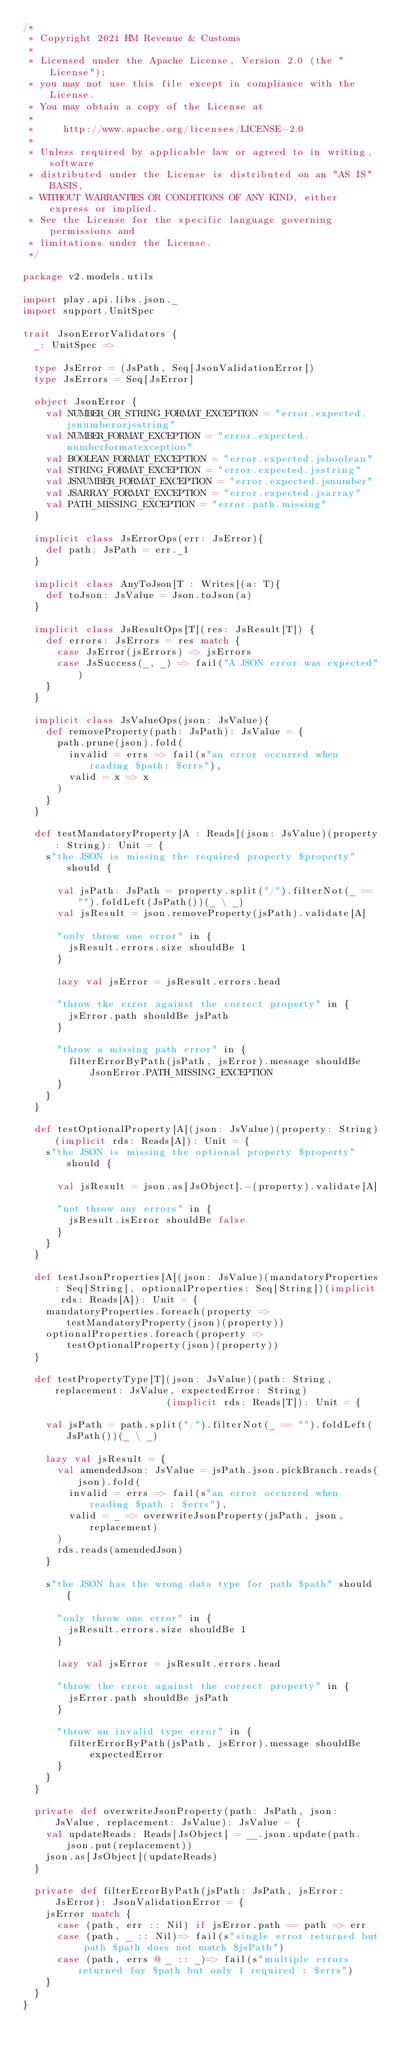Convert code to text. <code><loc_0><loc_0><loc_500><loc_500><_Scala_>/*
 * Copyright 2021 HM Revenue & Customs
 *
 * Licensed under the Apache License, Version 2.0 (the "License");
 * you may not use this file except in compliance with the License.
 * You may obtain a copy of the License at
 *
 *     http://www.apache.org/licenses/LICENSE-2.0
 *
 * Unless required by applicable law or agreed to in writing, software
 * distributed under the License is distributed on an "AS IS" BASIS,
 * WITHOUT WARRANTIES OR CONDITIONS OF ANY KIND, either express or implied.
 * See the License for the specific language governing permissions and
 * limitations under the License.
 */

package v2.models.utils

import play.api.libs.json._
import support.UnitSpec

trait JsonErrorValidators {
  _: UnitSpec =>

  type JsError = (JsPath, Seq[JsonValidationError])
  type JsErrors = Seq[JsError]

  object JsonError {
    val NUMBER_OR_STRING_FORMAT_EXCEPTION = "error.expected.jsnumberorjsstring"
    val NUMBER_FORMAT_EXCEPTION = "error.expected.numberformatexception"
    val BOOLEAN_FORMAT_EXCEPTION = "error.expected.jsboolean"
    val STRING_FORMAT_EXCEPTION = "error.expected.jsstring"
    val JSNUMBER_FORMAT_EXCEPTION = "error.expected.jsnumber"
    val JSARRAY_FORMAT_EXCEPTION = "error.expected.jsarray"
    val PATH_MISSING_EXCEPTION = "error.path.missing"
  }

  implicit class JsErrorOps(err: JsError){
    def path: JsPath = err._1
  }

  implicit class AnyToJson[T : Writes](a: T){
    def toJson: JsValue = Json.toJson(a)
  }

  implicit class JsResultOps[T](res: JsResult[T]) {
    def errors: JsErrors = res match {
      case JsError(jsErrors) => jsErrors
      case JsSuccess(_, _) => fail("A JSON error was expected")
    }
  }

  implicit class JsValueOps(json: JsValue){
    def removeProperty(path: JsPath): JsValue = {
      path.prune(json).fold(
        invalid = errs => fail(s"an error occurred when reading $path: $errs"),
        valid = x => x
      )
    }
  }

  def testMandatoryProperty[A : Reads](json: JsValue)(property: String): Unit = {
    s"the JSON is missing the required property $property" should {

      val jsPath: JsPath = property.split("/").filterNot(_ == "").foldLeft(JsPath())(_ \ _)
      val jsResult = json.removeProperty(jsPath).validate[A]

      "only throw one error" in {
        jsResult.errors.size shouldBe 1
      }

      lazy val jsError = jsResult.errors.head

      "throw the error against the correct property" in {
        jsError.path shouldBe jsPath
      }

      "throw a missing path error" in {
        filterErrorByPath(jsPath, jsError).message shouldBe JsonError.PATH_MISSING_EXCEPTION
      }
    }
  }

  def testOptionalProperty[A](json: JsValue)(property: String)(implicit rds: Reads[A]): Unit = {
    s"the JSON is missing the optional property $property" should {

      val jsResult = json.as[JsObject].-(property).validate[A]

      "not throw any errors" in {
        jsResult.isError shouldBe false
      }
    }
  }

  def testJsonProperties[A](json: JsValue)(mandatoryProperties: Seq[String], optionalProperties: Seq[String])(implicit rds: Reads[A]): Unit = {
    mandatoryProperties.foreach(property => testMandatoryProperty(json)(property))
    optionalProperties.foreach(property => testOptionalProperty(json)(property))
  }

  def testPropertyType[T](json: JsValue)(path: String, replacement: JsValue, expectedError: String)
                         (implicit rds: Reads[T]): Unit = {

    val jsPath = path.split("/").filterNot(_ == "").foldLeft(JsPath())(_ \ _)

    lazy val jsResult = {
      val amendedJson: JsValue = jsPath.json.pickBranch.reads(json).fold(
        invalid = errs => fail(s"an error occurred when reading $path : $errs"),
        valid = _ => overwriteJsonProperty(jsPath, json, replacement)
      )
      rds.reads(amendedJson)
    }

    s"the JSON has the wrong data type for path $path" should {

      "only throw one error" in {
        jsResult.errors.size shouldBe 1
      }

      lazy val jsError = jsResult.errors.head

      "throw the error against the correct property" in {
        jsError.path shouldBe jsPath
      }

      "throw an invalid type error" in {
        filterErrorByPath(jsPath, jsError).message shouldBe expectedError
      }
    }
  }

  private def overwriteJsonProperty(path: JsPath, json: JsValue, replacement: JsValue): JsValue = {
    val updateReads: Reads[JsObject] = __.json.update(path.json.put(replacement))
    json.as[JsObject](updateReads)
  }

  private def filterErrorByPath(jsPath: JsPath, jsError: JsError): JsonValidationError = {
    jsError match {
      case (path, err :: Nil) if jsError.path == path => err
      case (path, _ :: Nil)=> fail(s"single error returned but path $path does not match $jsPath")
      case (path, errs @ _ :: _)=> fail(s"multiple errors returned for $path but only 1 required : $errs")
    }
  }
}
</code> 